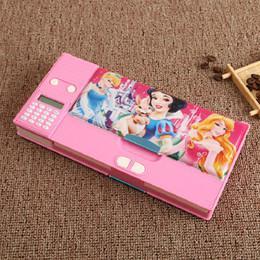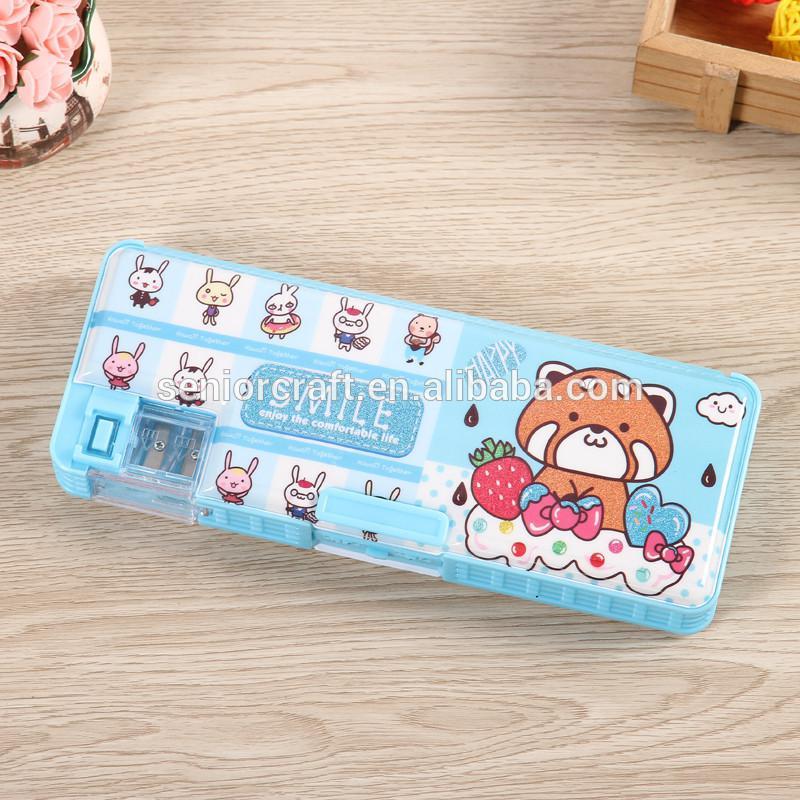The first image is the image on the left, the second image is the image on the right. Considering the images on both sides, is "The right image contains a pencil holder that has a small drawer in the middle that is pulled out." valid? Answer yes or no. No. The first image is the image on the left, the second image is the image on the right. For the images shown, is this caption "Both of the cases is opened to reveal their items." true? Answer yes or no. No. 